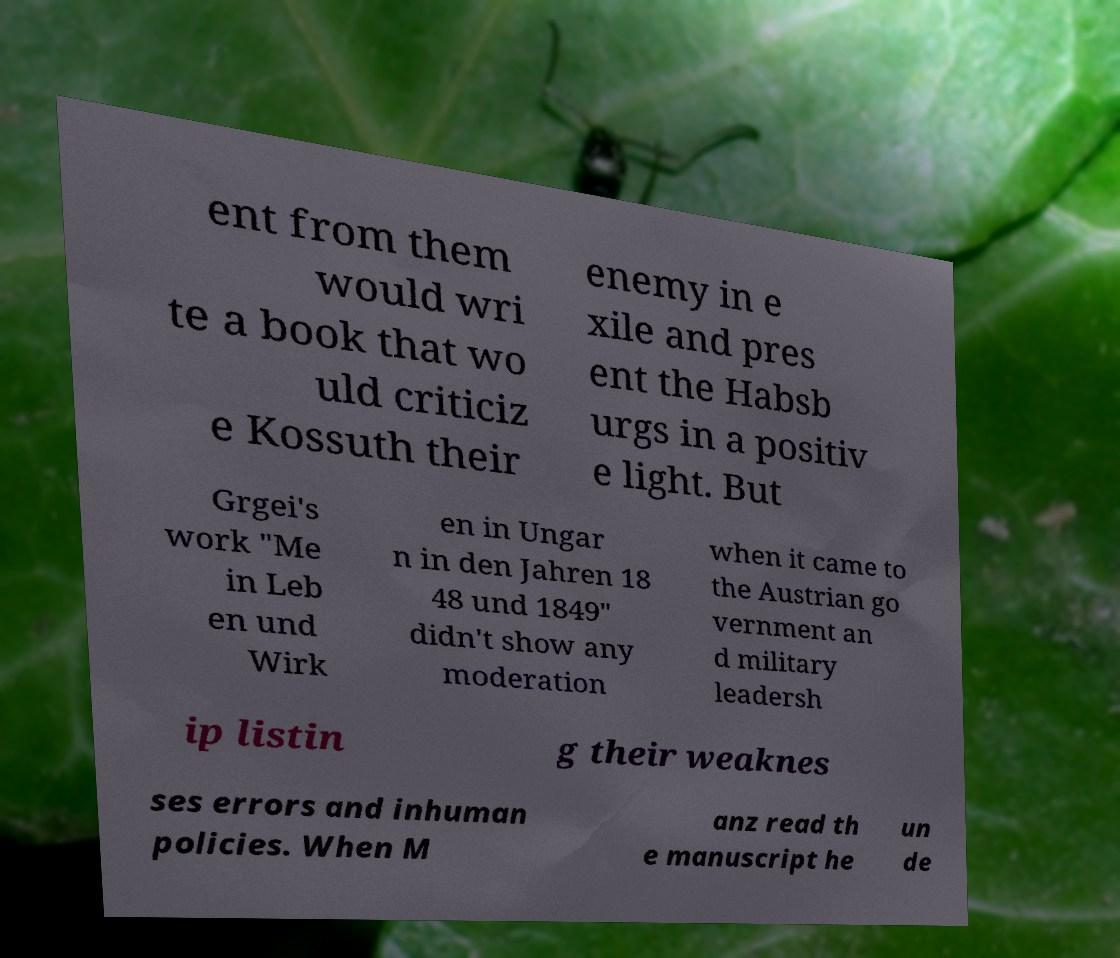Can you read and provide the text displayed in the image?This photo seems to have some interesting text. Can you extract and type it out for me? ent from them would wri te a book that wo uld criticiz e Kossuth their enemy in e xile and pres ent the Habsb urgs in a positiv e light. But Grgei's work "Me in Leb en und Wirk en in Ungar n in den Jahren 18 48 und 1849" didn't show any moderation when it came to the Austrian go vernment an d military leadersh ip listin g their weaknes ses errors and inhuman policies. When M anz read th e manuscript he un de 